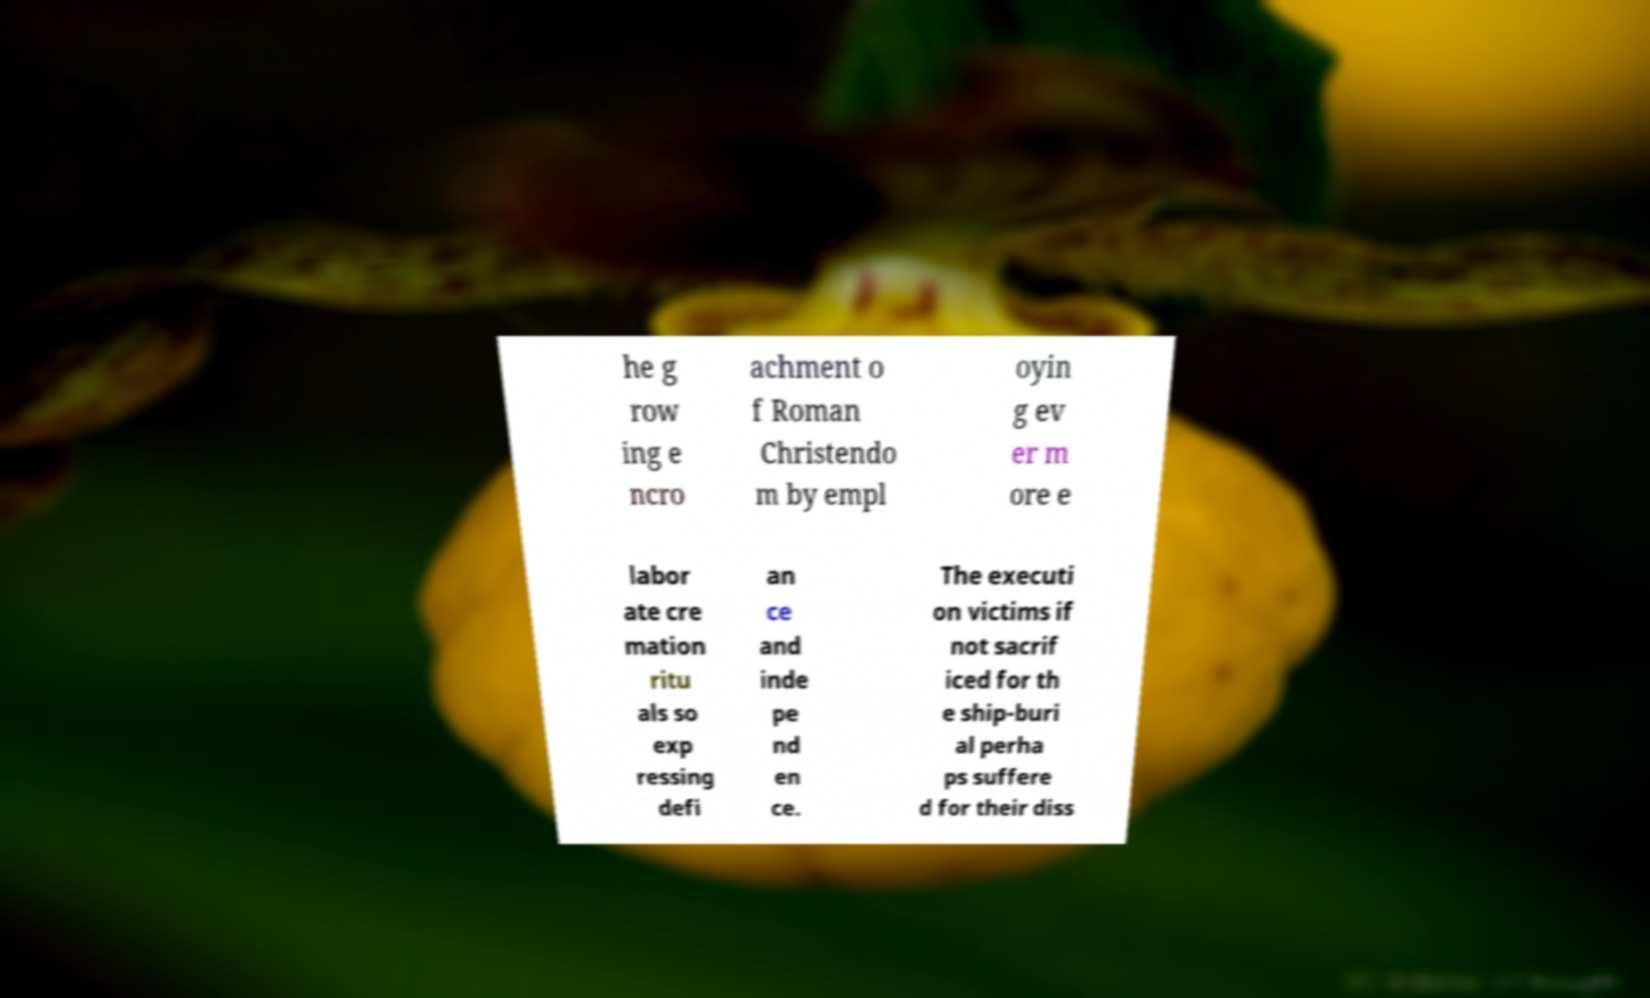Please read and relay the text visible in this image. What does it say? he g row ing e ncro achment o f Roman Christendo m by empl oyin g ev er m ore e labor ate cre mation ritu als so exp ressing defi an ce and inde pe nd en ce. The executi on victims if not sacrif iced for th e ship-buri al perha ps suffere d for their diss 